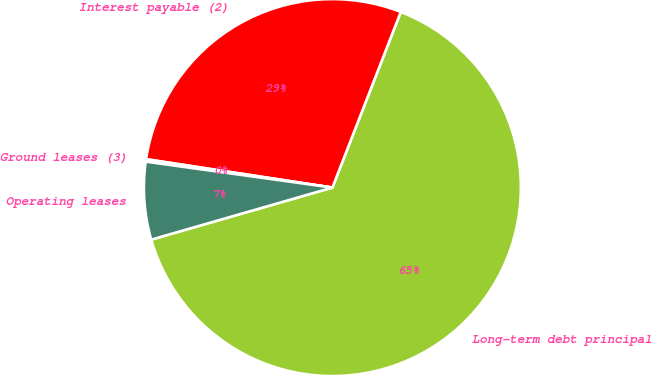Convert chart to OTSL. <chart><loc_0><loc_0><loc_500><loc_500><pie_chart><fcel>Long-term debt principal<fcel>Interest payable (2)<fcel>Ground leases (3)<fcel>Operating leases<nl><fcel>64.63%<fcel>28.5%<fcel>0.21%<fcel>6.65%<nl></chart> 